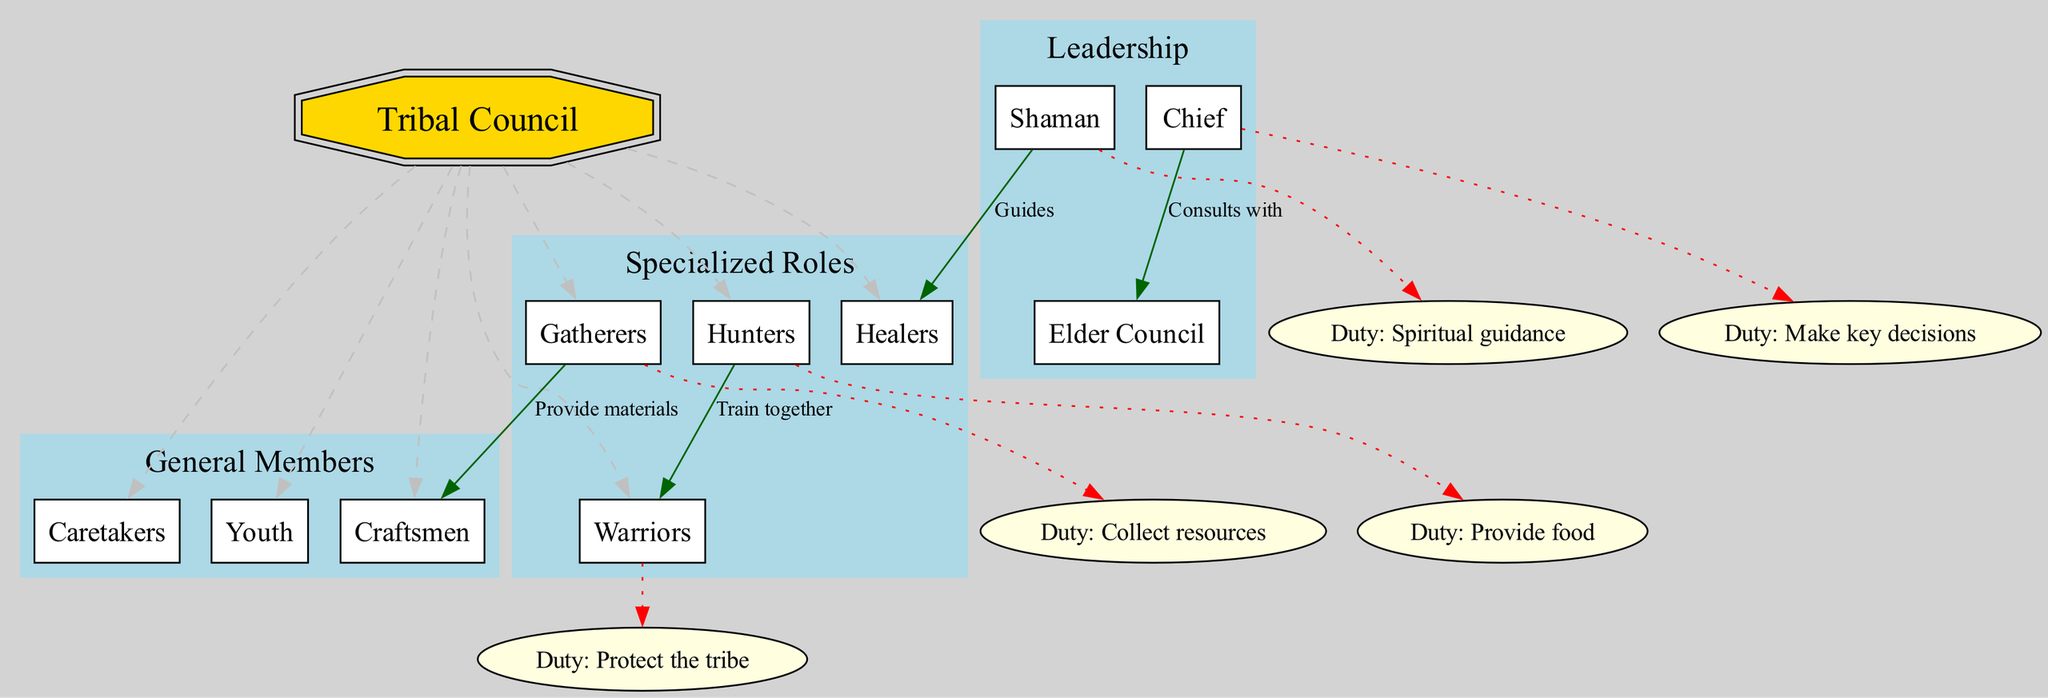What is the central node of the diagram? The central node is labeled "Tribal Council." It serves as the key focal point of the hierarchy depicted in the diagram.
Answer: Tribal Council How many levels are there in the hierarchy? There are three distinct levels: Leadership, Specialized Roles, and General Members. This can be counted from the hierarchy_levels in the diagram.
Answer: 3 Who provides spiritual guidance? The Shaman is responsible for providing spiritual guidance as indicated in the responsibilities section of the diagram.
Answer: Shaman What label connects the Chief to the Elder Council? The Chief is connected to the Elder Council with the label "Consults with," which describes the relationship between these roles.
Answer: Consults with Which group trains together with the Warriors? The Hunters train together with the Warriors as indicated by the connection "Train together" in the diagram.
Answer: Hunters What is the duty of the Gatherers? The duty of the Gatherers is to "Collect resources," which is explicitly stated in the responsibilities section of the diagram.
Answer: Collect resources Which role is responsible for making key decisions? The Chief has the responsibility to "Make key decisions," as outlined in the responsibilities section of the diagram.
Answer: Chief How many specialized roles are mentioned in the diagram? There are four specialized roles listed: Hunters, Gatherers, Healers, and Warriors. This count comes from the specialized roles level in the diagram.
Answer: 4 Who provides food for the tribe? The Hunters are tasked with providing food as indicated by their responsibility in the diagram.
Answer: Hunters 